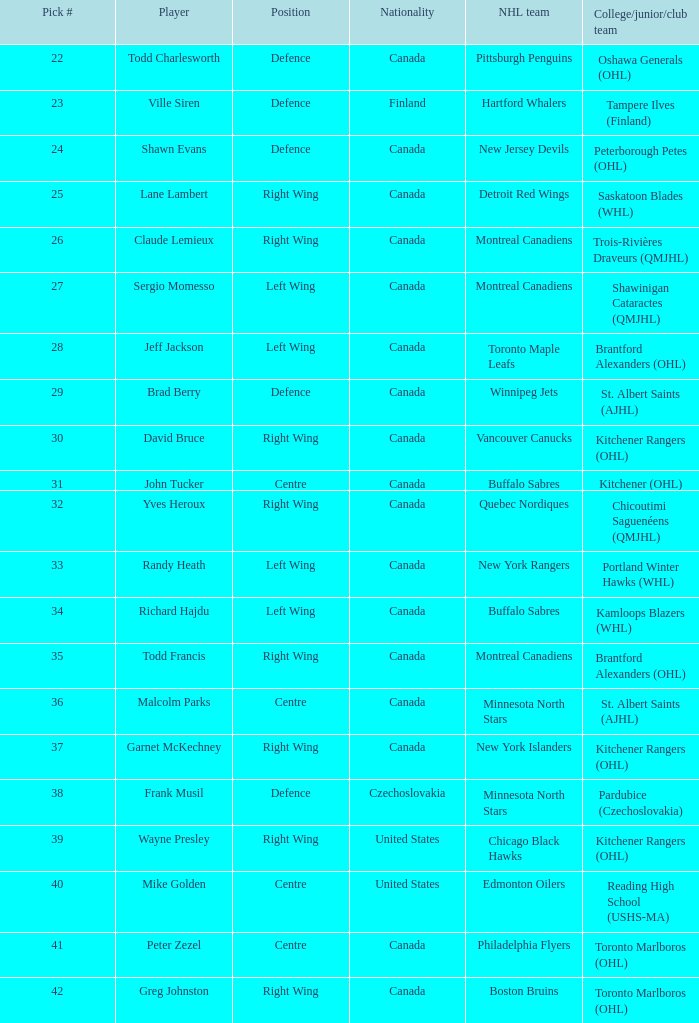What is the standing of the nhl team toronto maple leafs? Left Wing. 